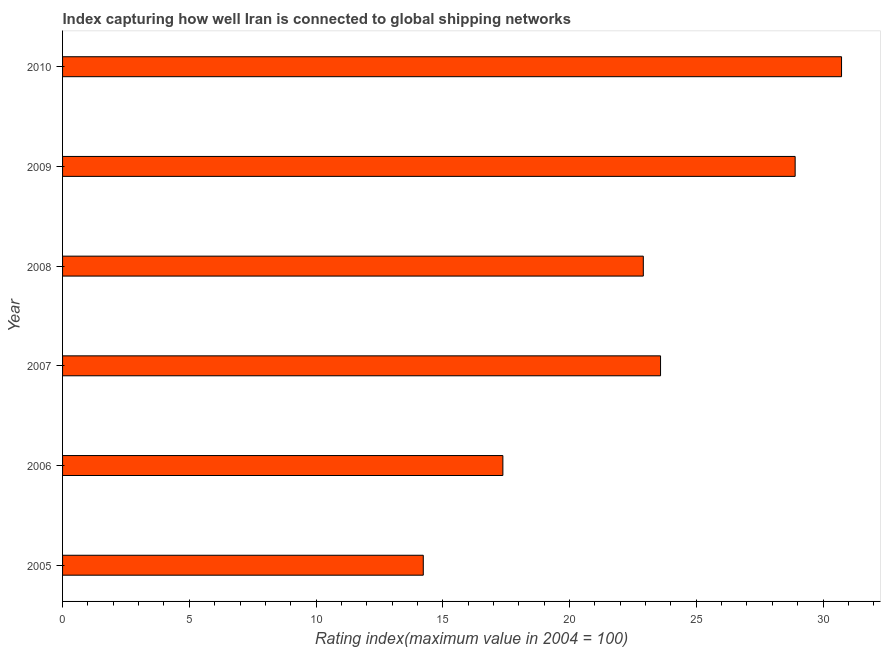What is the title of the graph?
Ensure brevity in your answer.  Index capturing how well Iran is connected to global shipping networks. What is the label or title of the X-axis?
Offer a terse response. Rating index(maximum value in 2004 = 100). What is the liner shipping connectivity index in 2007?
Provide a short and direct response. 23.59. Across all years, what is the maximum liner shipping connectivity index?
Offer a very short reply. 30.73. Across all years, what is the minimum liner shipping connectivity index?
Ensure brevity in your answer.  14.23. In which year was the liner shipping connectivity index maximum?
Provide a succinct answer. 2010. What is the sum of the liner shipping connectivity index?
Ensure brevity in your answer.  137.73. What is the difference between the liner shipping connectivity index in 2006 and 2010?
Your answer should be very brief. -13.36. What is the average liner shipping connectivity index per year?
Keep it short and to the point. 22.95. What is the median liner shipping connectivity index?
Provide a succinct answer. 23.25. What is the ratio of the liner shipping connectivity index in 2005 to that in 2007?
Your answer should be very brief. 0.6. What is the difference between the highest and the second highest liner shipping connectivity index?
Give a very brief answer. 1.83. Is the sum of the liner shipping connectivity index in 2006 and 2010 greater than the maximum liner shipping connectivity index across all years?
Give a very brief answer. Yes. What is the difference between the highest and the lowest liner shipping connectivity index?
Ensure brevity in your answer.  16.5. What is the Rating index(maximum value in 2004 = 100) in 2005?
Provide a short and direct response. 14.23. What is the Rating index(maximum value in 2004 = 100) in 2006?
Your answer should be compact. 17.37. What is the Rating index(maximum value in 2004 = 100) of 2007?
Provide a short and direct response. 23.59. What is the Rating index(maximum value in 2004 = 100) in 2008?
Your answer should be compact. 22.91. What is the Rating index(maximum value in 2004 = 100) of 2009?
Offer a terse response. 28.9. What is the Rating index(maximum value in 2004 = 100) of 2010?
Ensure brevity in your answer.  30.73. What is the difference between the Rating index(maximum value in 2004 = 100) in 2005 and 2006?
Provide a short and direct response. -3.14. What is the difference between the Rating index(maximum value in 2004 = 100) in 2005 and 2007?
Ensure brevity in your answer.  -9.36. What is the difference between the Rating index(maximum value in 2004 = 100) in 2005 and 2008?
Your answer should be very brief. -8.68. What is the difference between the Rating index(maximum value in 2004 = 100) in 2005 and 2009?
Provide a succinct answer. -14.67. What is the difference between the Rating index(maximum value in 2004 = 100) in 2005 and 2010?
Provide a succinct answer. -16.5. What is the difference between the Rating index(maximum value in 2004 = 100) in 2006 and 2007?
Your answer should be compact. -6.22. What is the difference between the Rating index(maximum value in 2004 = 100) in 2006 and 2008?
Ensure brevity in your answer.  -5.54. What is the difference between the Rating index(maximum value in 2004 = 100) in 2006 and 2009?
Keep it short and to the point. -11.53. What is the difference between the Rating index(maximum value in 2004 = 100) in 2006 and 2010?
Your answer should be compact. -13.36. What is the difference between the Rating index(maximum value in 2004 = 100) in 2007 and 2008?
Your answer should be very brief. 0.68. What is the difference between the Rating index(maximum value in 2004 = 100) in 2007 and 2009?
Make the answer very short. -5.31. What is the difference between the Rating index(maximum value in 2004 = 100) in 2007 and 2010?
Provide a succinct answer. -7.14. What is the difference between the Rating index(maximum value in 2004 = 100) in 2008 and 2009?
Offer a terse response. -5.99. What is the difference between the Rating index(maximum value in 2004 = 100) in 2008 and 2010?
Give a very brief answer. -7.82. What is the difference between the Rating index(maximum value in 2004 = 100) in 2009 and 2010?
Your response must be concise. -1.83. What is the ratio of the Rating index(maximum value in 2004 = 100) in 2005 to that in 2006?
Provide a short and direct response. 0.82. What is the ratio of the Rating index(maximum value in 2004 = 100) in 2005 to that in 2007?
Your response must be concise. 0.6. What is the ratio of the Rating index(maximum value in 2004 = 100) in 2005 to that in 2008?
Your response must be concise. 0.62. What is the ratio of the Rating index(maximum value in 2004 = 100) in 2005 to that in 2009?
Your answer should be compact. 0.49. What is the ratio of the Rating index(maximum value in 2004 = 100) in 2005 to that in 2010?
Provide a short and direct response. 0.46. What is the ratio of the Rating index(maximum value in 2004 = 100) in 2006 to that in 2007?
Offer a very short reply. 0.74. What is the ratio of the Rating index(maximum value in 2004 = 100) in 2006 to that in 2008?
Keep it short and to the point. 0.76. What is the ratio of the Rating index(maximum value in 2004 = 100) in 2006 to that in 2009?
Offer a terse response. 0.6. What is the ratio of the Rating index(maximum value in 2004 = 100) in 2006 to that in 2010?
Offer a very short reply. 0.56. What is the ratio of the Rating index(maximum value in 2004 = 100) in 2007 to that in 2008?
Offer a very short reply. 1.03. What is the ratio of the Rating index(maximum value in 2004 = 100) in 2007 to that in 2009?
Provide a short and direct response. 0.82. What is the ratio of the Rating index(maximum value in 2004 = 100) in 2007 to that in 2010?
Your answer should be compact. 0.77. What is the ratio of the Rating index(maximum value in 2004 = 100) in 2008 to that in 2009?
Ensure brevity in your answer.  0.79. What is the ratio of the Rating index(maximum value in 2004 = 100) in 2008 to that in 2010?
Offer a very short reply. 0.75. 